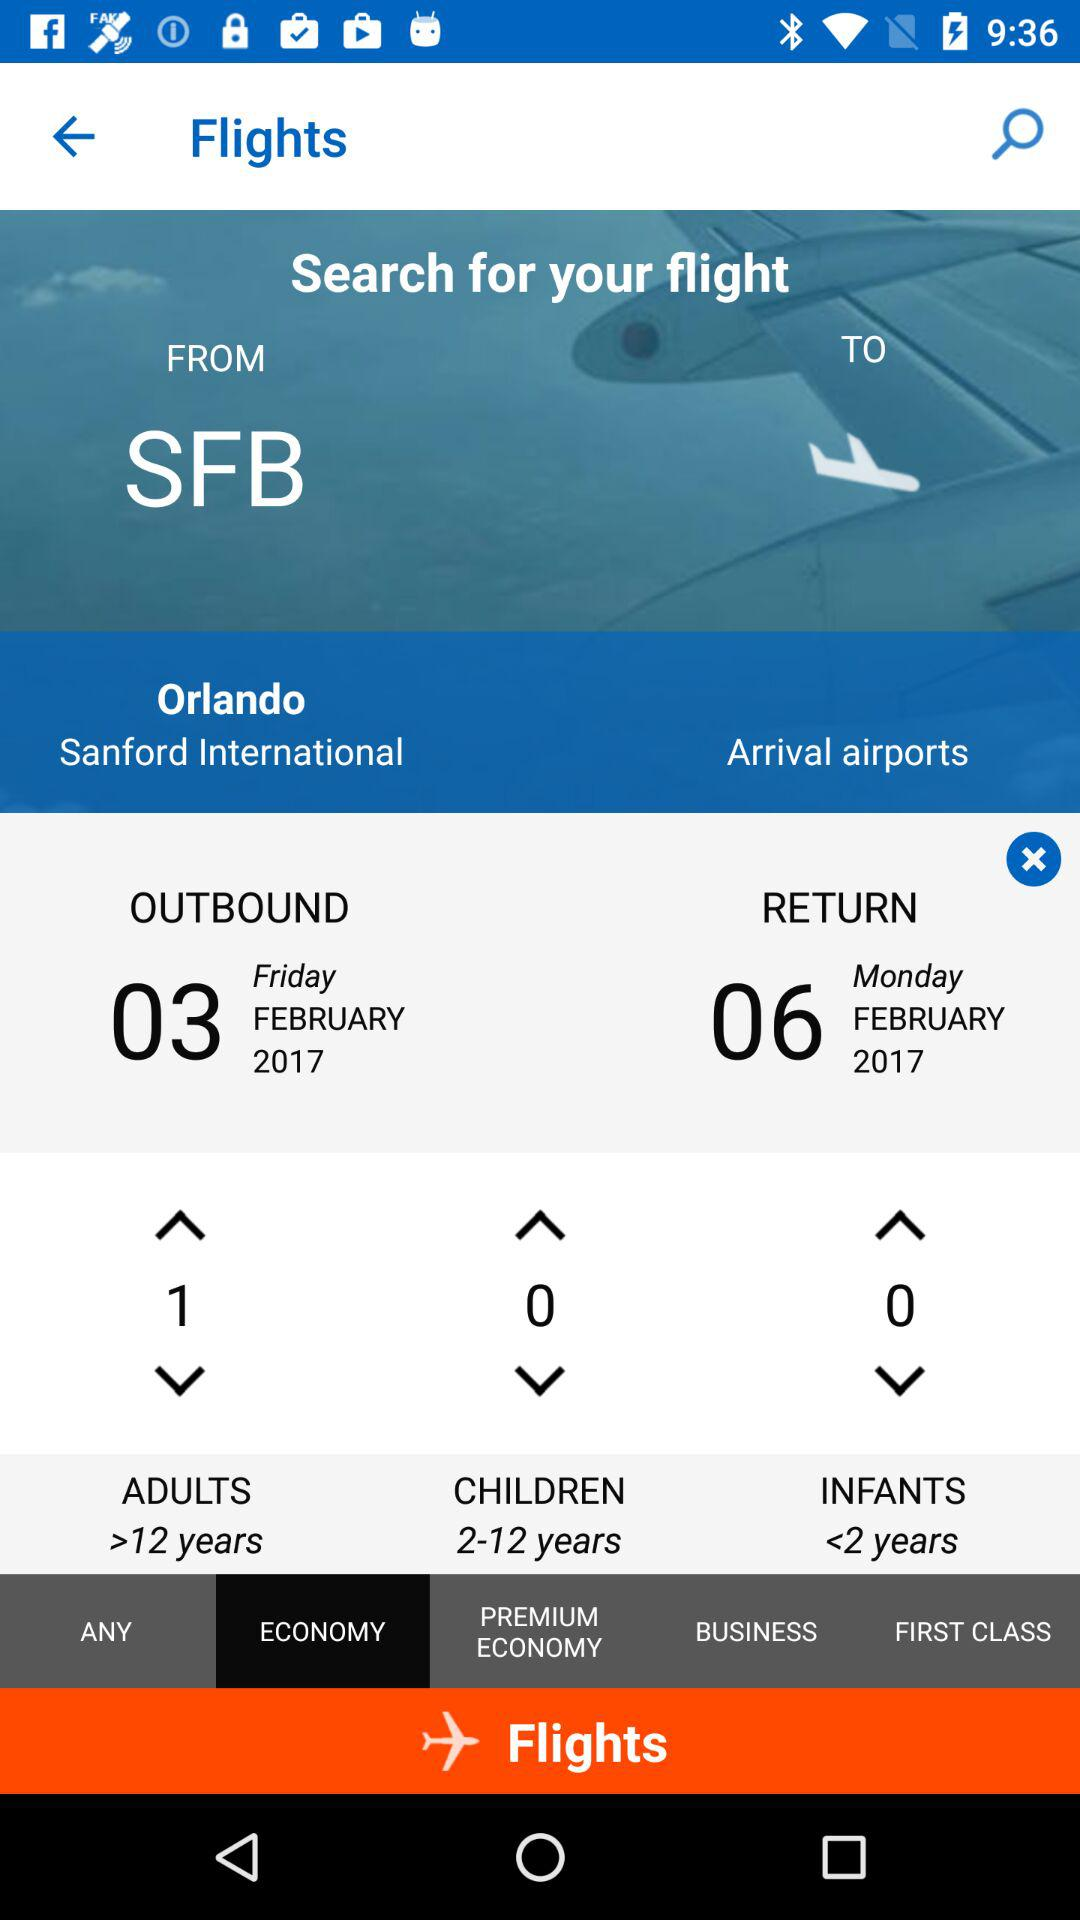What is the name of the city from where the journey will start? The name of the city is Orlando. 